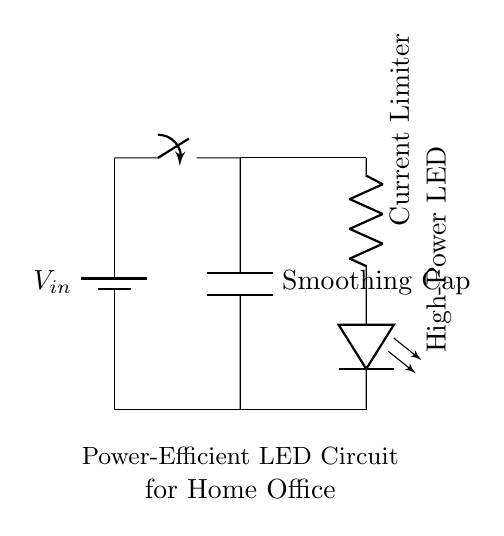What is the input voltage of this circuit? The input voltage is indicated by the battery symbol labeled as V_in, which typically represents the voltage supplied to the circuit.
Answer: V_in What component limits the current in this circuit? The circuit contains a resistor labeled as "Current Limiter," which is responsible for limiting the amount of current flowing through the circuit to prevent damage.
Answer: Current Limiter What type of capacitor is used in this circuit? The circuit has a capacitor labeled as "Smoothing Cap," which is used to smooth out voltage fluctuations and provide a stable voltage to the LED.
Answer: Smoothing Cap How many main components are in the circuit? The circuit has four main components: a battery, a switch, a resistor, and a high-power LED. Counting these components gives a total of four.
Answer: Four Why is a smoothing capacitor necessary in this circuit? A smoothing capacitor is necessary to maintain a steady voltage across the LED by reducing voltage ripples caused by fluctuations in current. This ensures that the LED receives a consistent power supply, which is especially important for performance and longevity.
Answer: To stabilize voltage What type of LED is in this circuit? The circuit features a "High-Power LED," which is designed to emit a large amount of light while being energy efficient.
Answer: High-Power LED What function does the switch serve in this circuit? The switch is used to control the flow of electricity in the circuit. By opening or closing the switch, you can turn the circuit on or off, which in turn powers the LED on or off.
Answer: Control electricity flow 